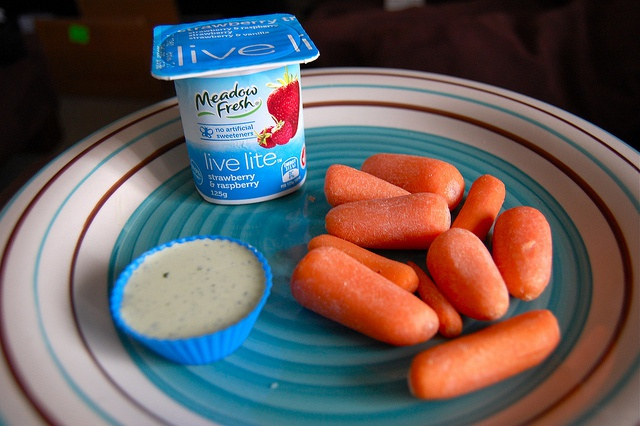Describe the objects in this image and their specific colors. I can see cup in black, blue, lightgray, and gray tones, cup in black, darkgray, lightblue, and blue tones, bowl in black, darkgray, lightblue, and blue tones, carrot in black, red, salmon, brown, and maroon tones, and carrot in black, salmon, red, and brown tones in this image. 